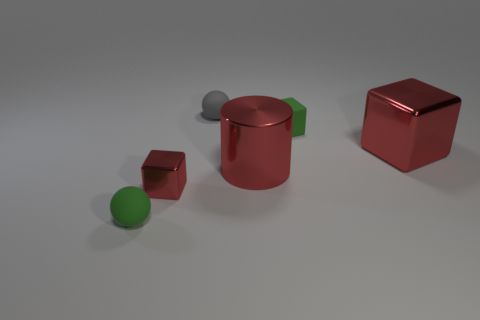How many things are either red metal cubes on the left side of the tiny matte block or matte spheres?
Give a very brief answer. 3. What shape is the large red thing that is the same material as the large cylinder?
Offer a terse response. Cube. What number of tiny green objects have the same shape as the gray object?
Your response must be concise. 1. What is the large cylinder made of?
Ensure brevity in your answer.  Metal. Is the color of the tiny shiny cube the same as the shiny cube that is behind the small metal block?
Ensure brevity in your answer.  Yes. How many cylinders are either red metallic things or tiny metallic objects?
Keep it short and to the point. 1. The ball that is to the right of the green sphere is what color?
Keep it short and to the point. Gray. There is a tiny metal object that is the same color as the big metal block; what is its shape?
Provide a short and direct response. Cube. What number of other green spheres have the same size as the green sphere?
Provide a succinct answer. 0. Is the shape of the green object right of the tiny gray sphere the same as the red shiny thing that is left of the tiny gray thing?
Ensure brevity in your answer.  Yes. 